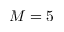Convert formula to latex. <formula><loc_0><loc_0><loc_500><loc_500>M = 5</formula> 